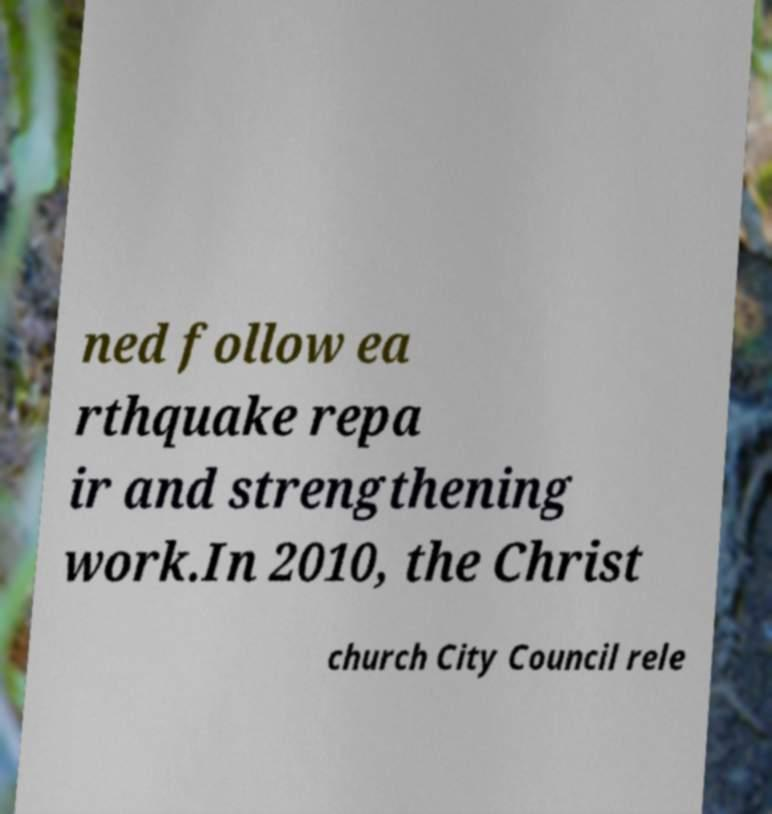Could you assist in decoding the text presented in this image and type it out clearly? ned follow ea rthquake repa ir and strengthening work.In 2010, the Christ church City Council rele 